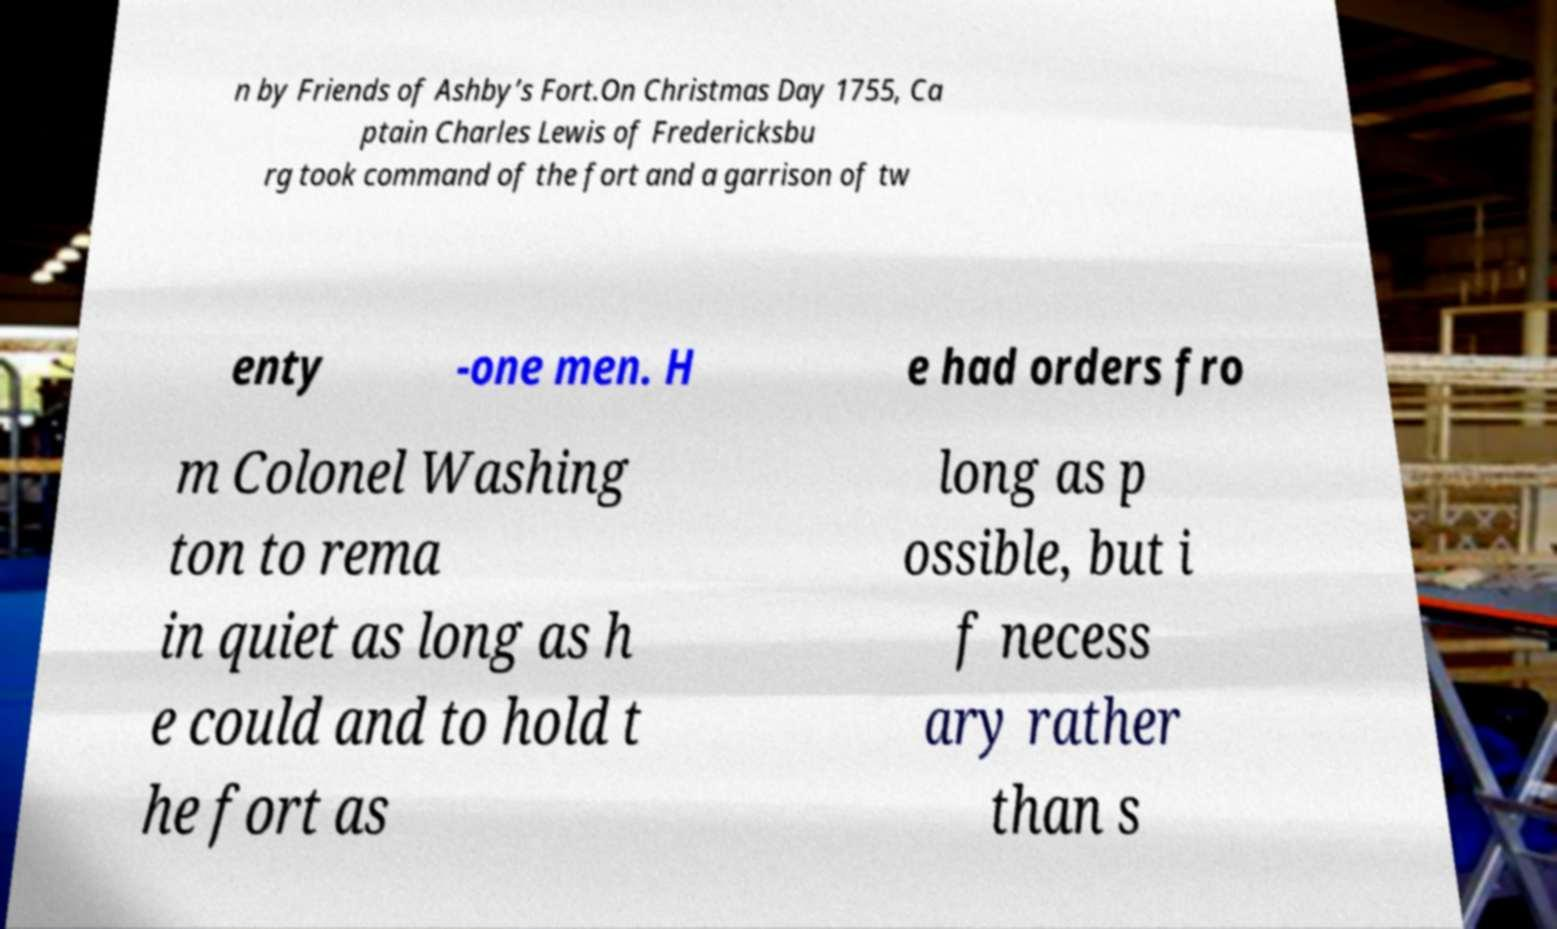Can you read and provide the text displayed in the image?This photo seems to have some interesting text. Can you extract and type it out for me? n by Friends of Ashby’s Fort.On Christmas Day 1755, Ca ptain Charles Lewis of Fredericksbu rg took command of the fort and a garrison of tw enty -one men. H e had orders fro m Colonel Washing ton to rema in quiet as long as h e could and to hold t he fort as long as p ossible, but i f necess ary rather than s 